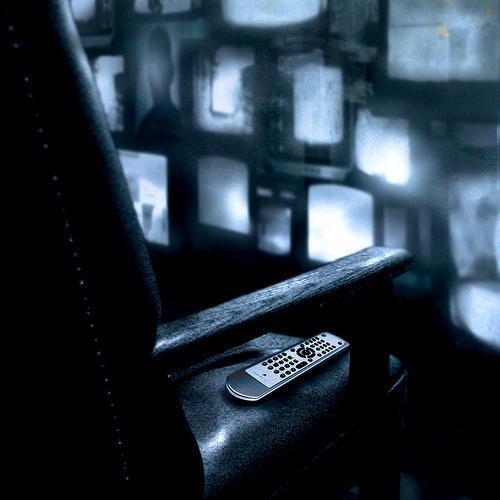How many chairs are there?
Give a very brief answer. 1. 